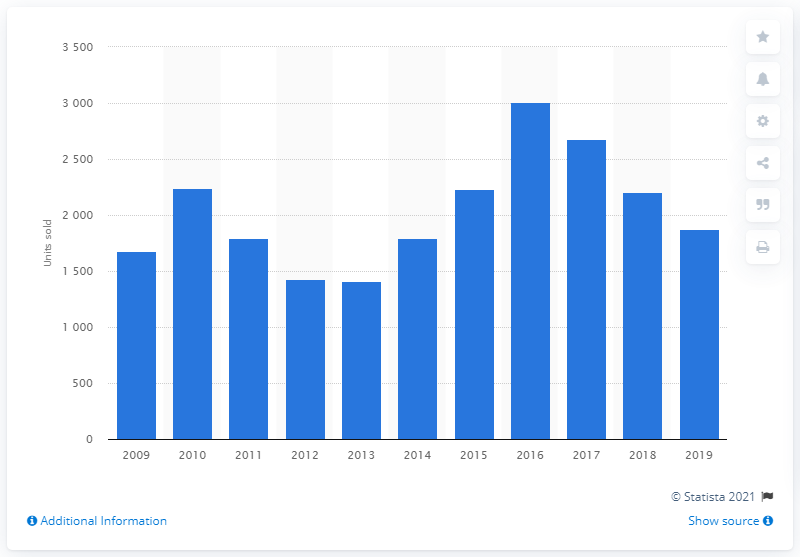Highlight a few significant elements in this photo. Sales of Irish Mazda vehicles declined in 2017. 